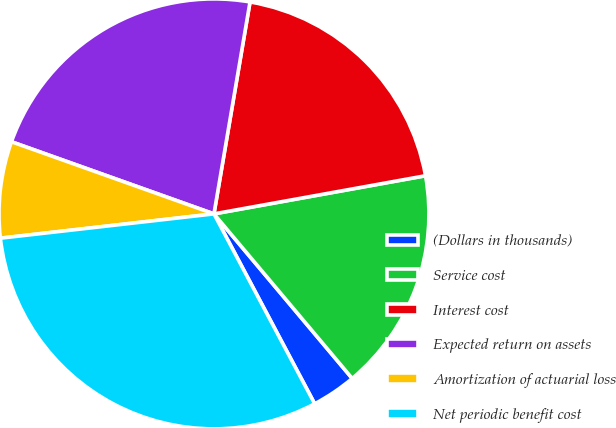Convert chart to OTSL. <chart><loc_0><loc_0><loc_500><loc_500><pie_chart><fcel>(Dollars in thousands)<fcel>Service cost<fcel>Interest cost<fcel>Expected return on assets<fcel>Amortization of actuarial loss<fcel>Net periodic benefit cost<nl><fcel>3.36%<fcel>16.72%<fcel>19.48%<fcel>22.24%<fcel>7.25%<fcel>30.96%<nl></chart> 